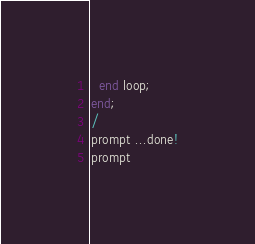Convert code to text. <code><loc_0><loc_0><loc_500><loc_500><_SQL_>  end loop;
end;
/
prompt ...done!
prompt</code> 